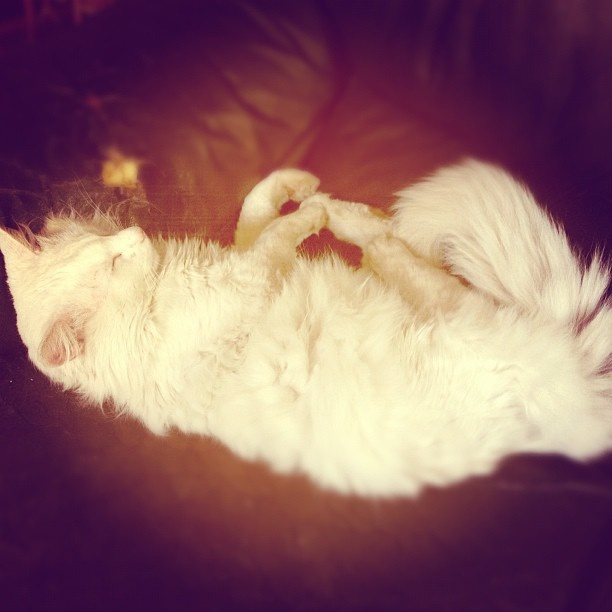Describe the objects in this image and their specific colors. I can see couch in navy, purple, and brown tones and cat in navy, beige, lightyellow, and tan tones in this image. 